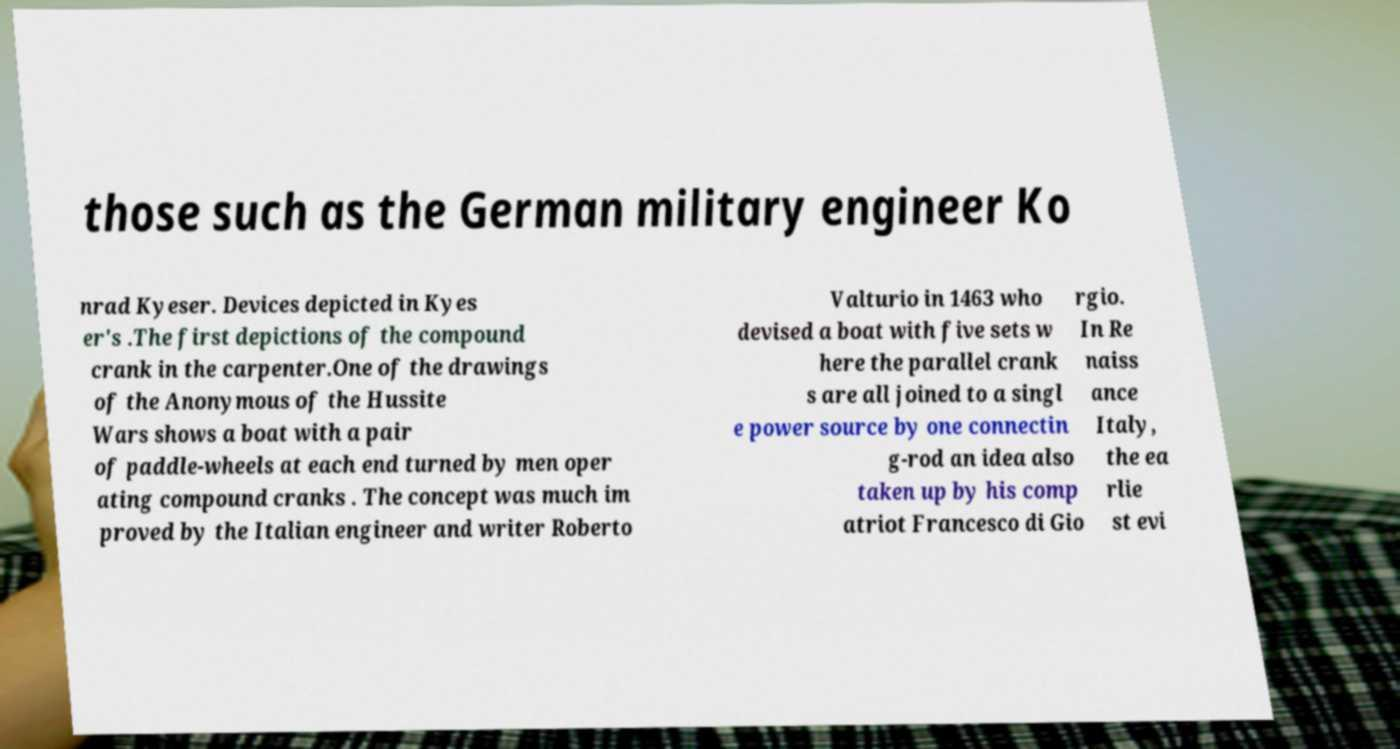Please read and relay the text visible in this image. What does it say? those such as the German military engineer Ko nrad Kyeser. Devices depicted in Kyes er's .The first depictions of the compound crank in the carpenter.One of the drawings of the Anonymous of the Hussite Wars shows a boat with a pair of paddle-wheels at each end turned by men oper ating compound cranks . The concept was much im proved by the Italian engineer and writer Roberto Valturio in 1463 who devised a boat with five sets w here the parallel crank s are all joined to a singl e power source by one connectin g-rod an idea also taken up by his comp atriot Francesco di Gio rgio. In Re naiss ance Italy, the ea rlie st evi 